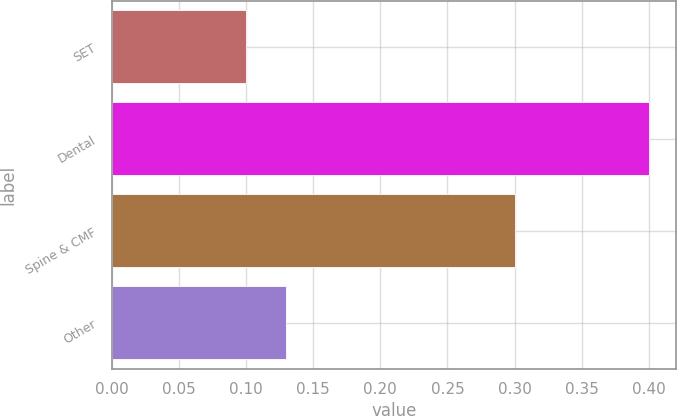Convert chart to OTSL. <chart><loc_0><loc_0><loc_500><loc_500><bar_chart><fcel>SET<fcel>Dental<fcel>Spine & CMF<fcel>Other<nl><fcel>0.1<fcel>0.4<fcel>0.3<fcel>0.13<nl></chart> 